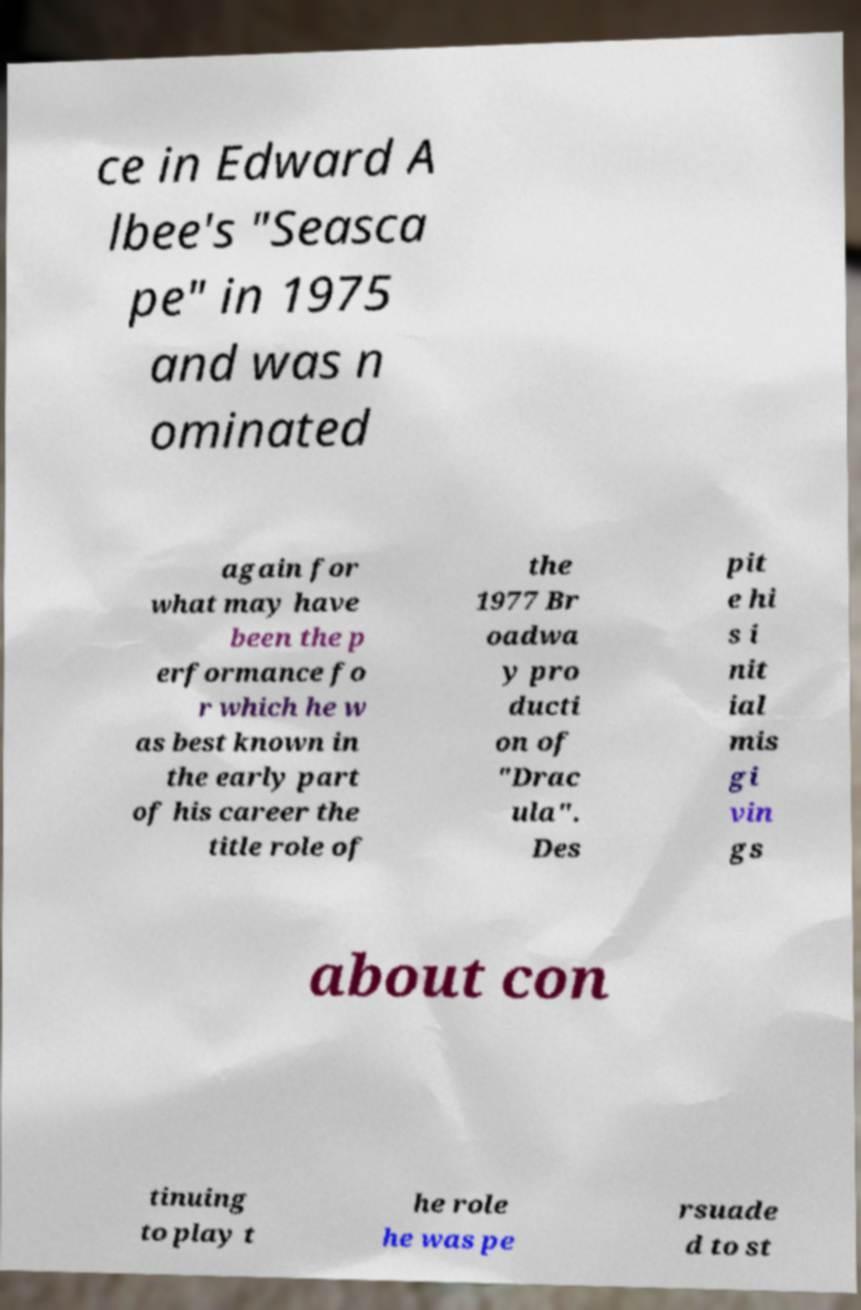Could you extract and type out the text from this image? ce in Edward A lbee's "Seasca pe" in 1975 and was n ominated again for what may have been the p erformance fo r which he w as best known in the early part of his career the title role of the 1977 Br oadwa y pro ducti on of "Drac ula". Des pit e hi s i nit ial mis gi vin gs about con tinuing to play t he role he was pe rsuade d to st 